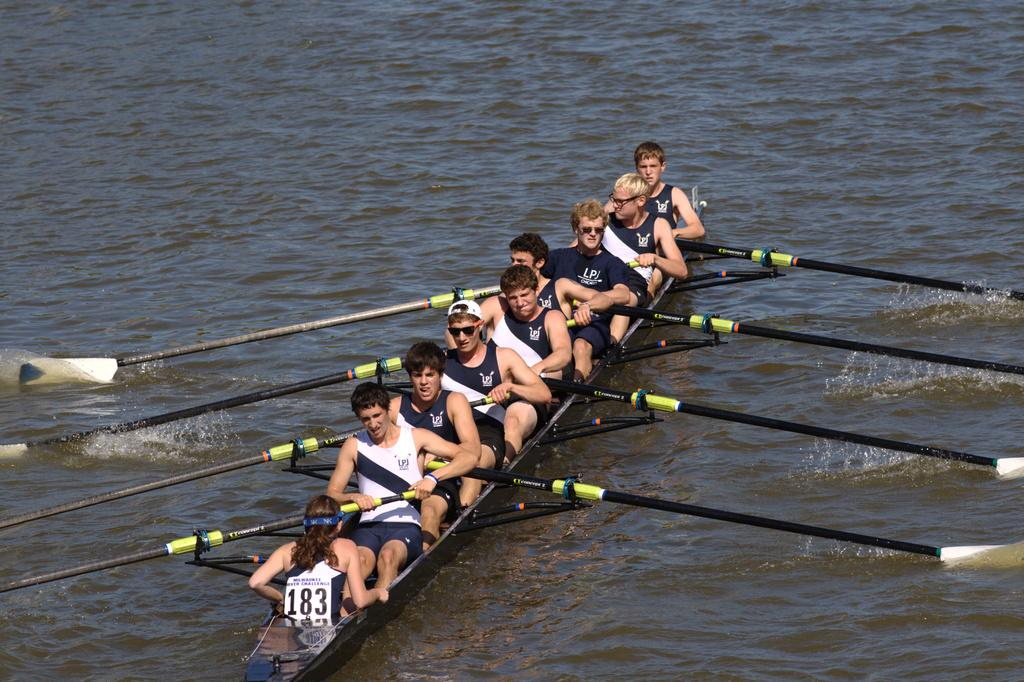What is the main feature of the image? The main feature of the image is a river. What activity is taking place on the river? There are people in a boat on the river. What are the people using to propel the boat? The people are holding oar sticks. What color are the swimsuits worn by the people in the boat? The people are wearing black color swimsuits. What type of drug can be seen in the image? There is no drug present in the image. How many babies are visible in the boat? There are no babies visible in the boat; the image only shows people holding oar sticks. 